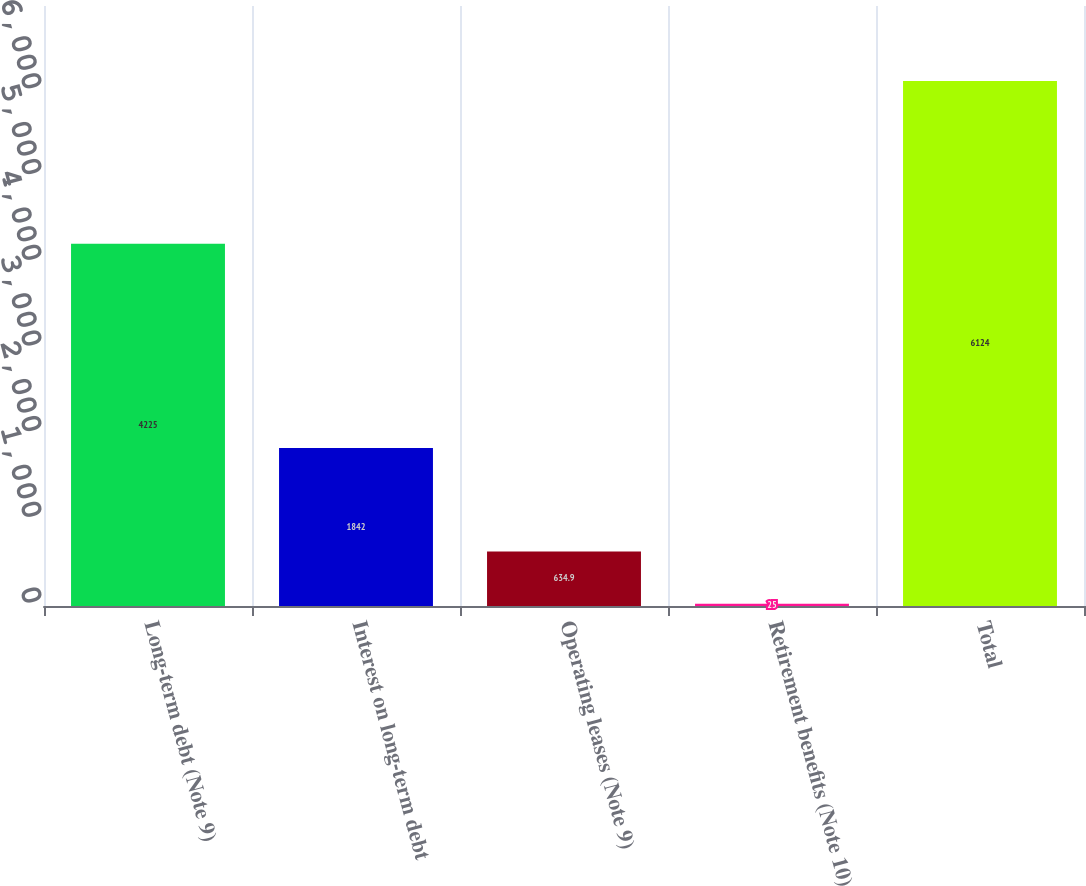Convert chart. <chart><loc_0><loc_0><loc_500><loc_500><bar_chart><fcel>Long-term debt (Note 9)<fcel>Interest on long-term debt<fcel>Operating leases (Note 9)<fcel>Retirement benefits (Note 10)<fcel>Total<nl><fcel>4225<fcel>1842<fcel>634.9<fcel>25<fcel>6124<nl></chart> 